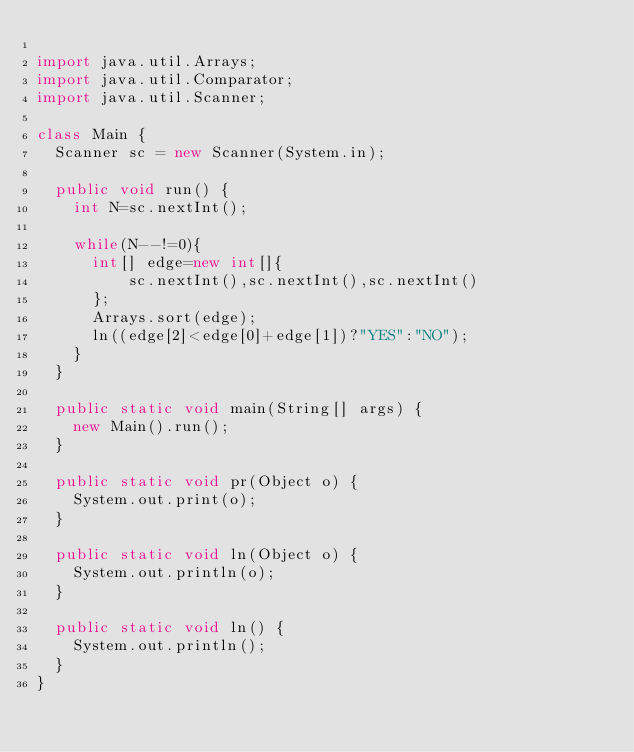Convert code to text. <code><loc_0><loc_0><loc_500><loc_500><_Java_>
import java.util.Arrays;
import java.util.Comparator;
import java.util.Scanner;

class Main {
	Scanner sc = new Scanner(System.in);

	public void run() {
		int N=sc.nextInt();
		
		while(N--!=0){
			int[] edge=new int[]{
					sc.nextInt(),sc.nextInt(),sc.nextInt()
			};
			Arrays.sort(edge);
			ln((edge[2]<edge[0]+edge[1])?"YES":"NO");
		}
	}

	public static void main(String[] args) {
		new Main().run();
	}

	public static void pr(Object o) {
		System.out.print(o);
	}

	public static void ln(Object o) {
		System.out.println(o);
	}

	public static void ln() {
		System.out.println();
	}
}</code> 